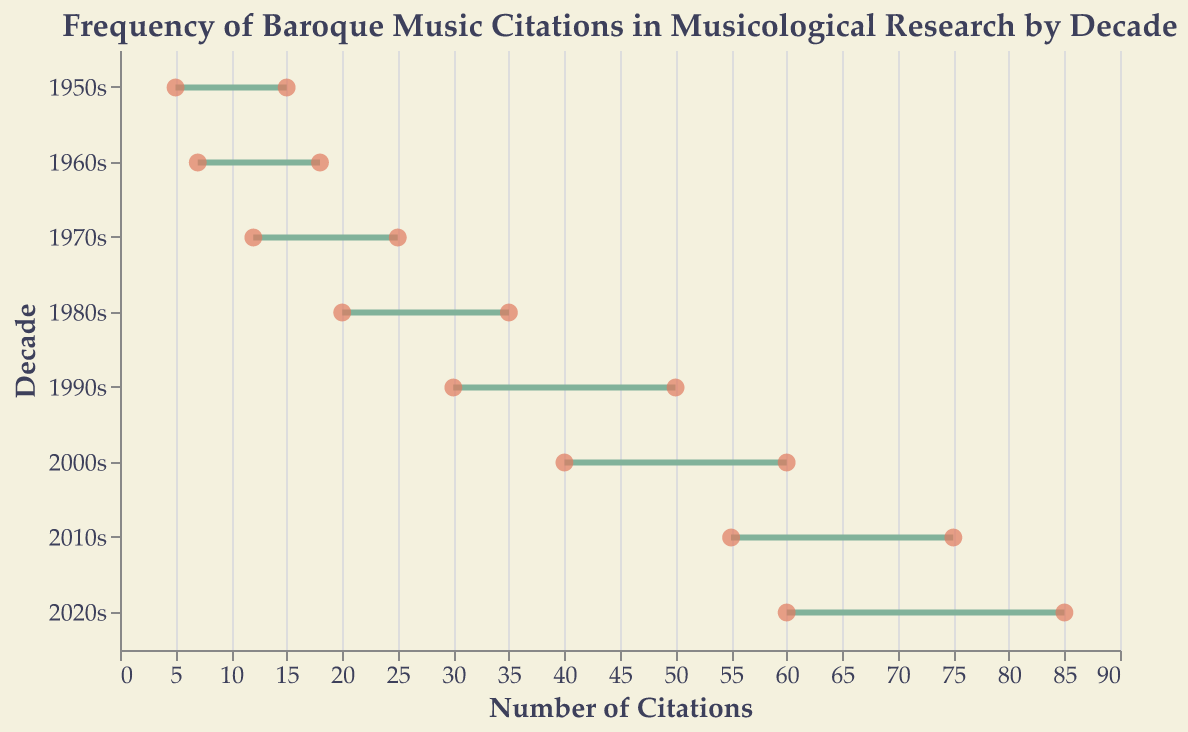What's the title of the plot? The title of the plot is prominently displayed at the top.
Answer: Frequency of Baroque Music Citations in Musicological Research by Decade How many decades are represented in the plot? By looking at the y-axis, which labels the decades, we can see that there are eight different decades.
Answer: 8 In which decade is the range of Baroque music citations the largest? The range is determined by the difference between the maximum and minimum citations for each decade, and the 2020s show the largest range from 60 to 85.
Answer: 2020s What is the minimum number of citations for the 1990s? The minimum number of citations for each decade is shown by the leftmost point of the range in the plot corresponding to that decade. For the 1990s, this point is at 30.
Answer: 30 What is the difference between the maximum citations in the 2000s and the 1980s? The maximum citations for the 2000s is 60, and for the 1980s, it is 35. Subtracting these two values gives 60 - 35.
Answer: 25 What decade has the fewest minimum citations? By comparing the leftmost points for each decade, the 1950s have the fewest minimum citations at 5.
Answer: 1950s Which decade shows the smallest increase in minimum citations compared to the previous decade? The differences in minimum citations between consecutive decades are: (7-5) for 1960s, (12-7) for 1970s, (20-12) for 1980s, (30-20) for 1990s, (40-30) for 2000s, (55-40) for 2010s, and (60-55) for 2020s. The smallest increase is (60-55), which is 5, observed between 2010s and 2020s.
Answer: 2020s In which decade do both the minimum and maximum citation counts reach their peak values? By checking for both the highest minimum and maximum values across the decades, the 2020s show both the highest minimum (60) and maximum (85) citation counts.
Answer: 2020s What's the average of the minimum citations across all decades? To find the average, sum the minimum citations for all decades: 5 (1950s) + 7 (1960s) + 12 (1970s) + 20 (1980s) + 30 (1990s) + 40 (2000s) + 55 (2010s) + 60 (2020s) = 229. Then, divide this by the number of decades (8). 229 / 8 = 28.625.
Answer: 28.625 